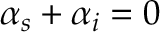<formula> <loc_0><loc_0><loc_500><loc_500>\alpha _ { s } + \alpha _ { i } = 0</formula> 